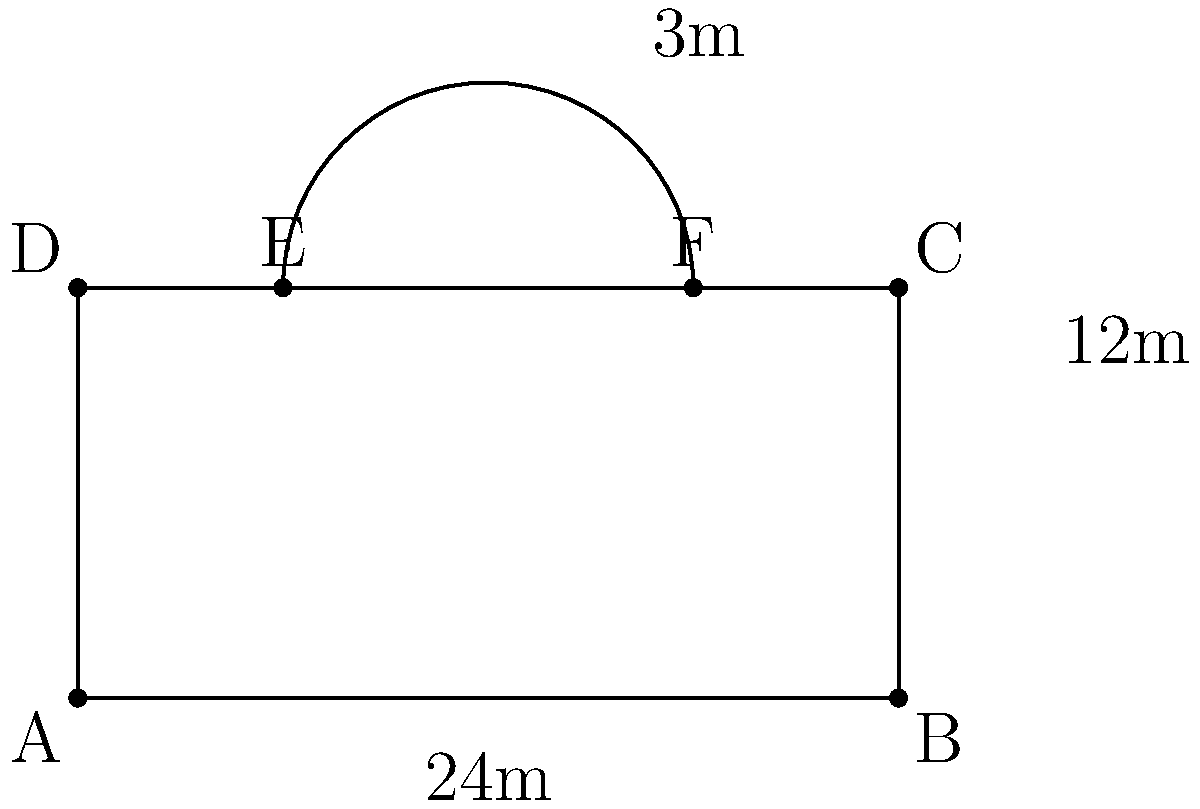As the administrative staff planning the upcoming music festival, you're tasked with calculating the total area of the auditorium, which includes a rectangular main space and a semi-circular stage extension. The rectangular part measures 24m by 12m, and the stage extension has a radius of 3m. What is the total area of the auditorium in square meters? Let's break this down step-by-step:

1) First, we need to calculate the area of the rectangular part:
   $A_{rectangle} = length \times width = 24m \times 12m = 288m^2$

2) Next, we calculate the area of the semi-circular stage extension:
   The area of a full circle is $\pi r^2$, so a semi-circle is half of that.
   $A_{semi-circle} = \frac{1}{2} \pi r^2 = \frac{1}{2} \times \pi \times 3^2 = \frac{9\pi}{2} m^2$

3) Now, we add these two areas together:
   $A_{total} = A_{rectangle} + A_{semi-circle}$
   $A_{total} = 288 + \frac{9\pi}{2}$

4) Let's calculate this:
   $\frac{9\pi}{2} \approx 14.14$
   $288 + 14.14 = 302.14$

5) Rounding to two decimal places:
   $A_{total} \approx 302.14m^2$

Therefore, the total area of the auditorium is approximately 302.14 square meters.
Answer: $302.14m^2$ 